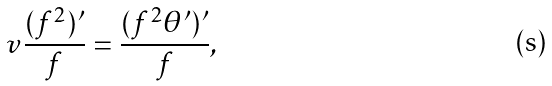<formula> <loc_0><loc_0><loc_500><loc_500>v \frac { ( f ^ { 2 } ) ^ { \prime } } { f } = \frac { ( f ^ { 2 } \theta ^ { \prime } ) ^ { \prime } } { f } ,</formula> 